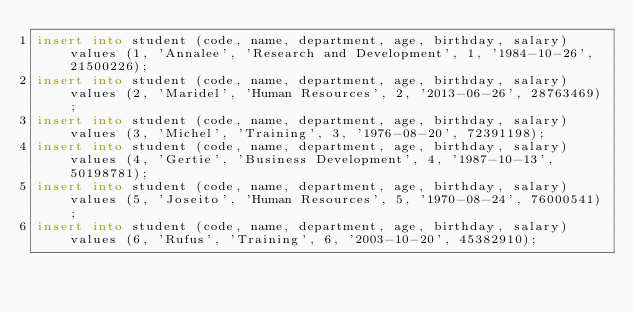<code> <loc_0><loc_0><loc_500><loc_500><_SQL_>insert into student (code, name, department, age, birthday, salary) values (1, 'Annalee', 'Research and Development', 1, '1984-10-26', 21500226);
insert into student (code, name, department, age, birthday, salary) values (2, 'Maridel', 'Human Resources', 2, '2013-06-26', 28763469);
insert into student (code, name, department, age, birthday, salary) values (3, 'Michel', 'Training', 3, '1976-08-20', 72391198);
insert into student (code, name, department, age, birthday, salary) values (4, 'Gertie', 'Business Development', 4, '1987-10-13', 50198781);
insert into student (code, name, department, age, birthday, salary) values (5, 'Joseito', 'Human Resources', 5, '1970-08-24', 76000541);
insert into student (code, name, department, age, birthday, salary) values (6, 'Rufus', 'Training', 6, '2003-10-20', 45382910);</code> 